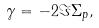<formula> <loc_0><loc_0><loc_500><loc_500>\gamma = - 2 \Im \Sigma _ { p } ,</formula> 